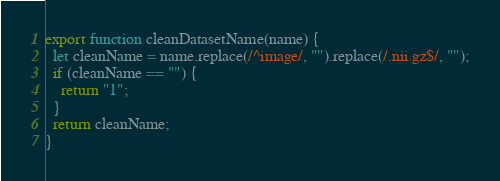Convert code to text. <code><loc_0><loc_0><loc_500><loc_500><_JavaScript_>export function cleanDatasetName(name) {
  let cleanName = name.replace(/^image/, "").replace(/.nii.gz$/, "");
  if (cleanName == "") {
    return "1";
  }
  return cleanName;
}
</code> 